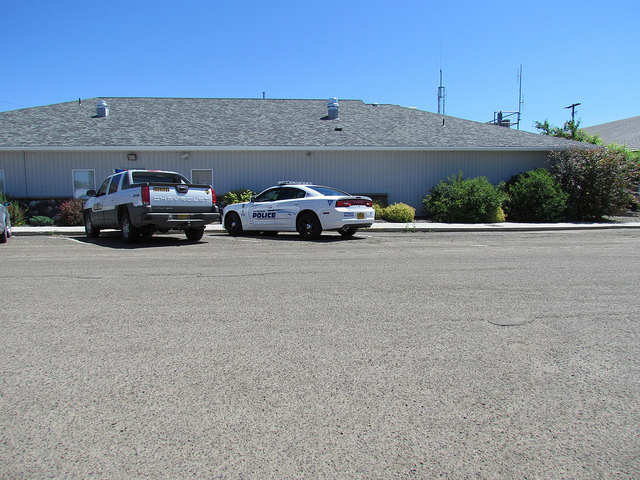<image>What type and model is the car? I am not sure about the type and model of the car. However, it could be a dodge charger, chevy, chrysler, ford escort, or camaro. What animals are on top of the car? I am not sure what animals are on top of the car. It could be none or it could be birds or dogs. What animals are on top of the car? There are no animals on top of the car. What type and model is the car? I don't know the exact type and model of the car. Some possibilities are 'chevy', 'sedan', 'dodge charger', 'chrysler', 'police car', 'ford escort', or 'camaro'. 